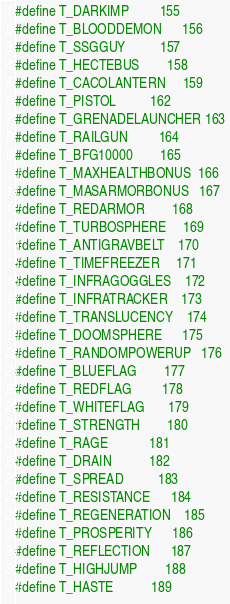<code> <loc_0><loc_0><loc_500><loc_500><_C_>
#define T_DARKIMP         155
#define T_BLOODDEMON      156
#define T_SSGGUY          157
#define T_HECTEBUS        158
#define T_CACOLANTERN     159
#define T_PISTOL          162
#define T_GRENADELAUNCHER 163
#define T_RAILGUN         164
#define T_BFG10000        165
#define T_MAXHEALTHBONUS  166
#define T_MASARMORBONUS   167
#define T_REDARMOR        168
#define T_TURBOSPHERE     169
#define T_ANTIGRAVBELT    170
#define T_TIMEFREEZER     171
#define T_INFRAGOGGLES    172
#define T_INFRATRACKER    173
#define T_TRANSLUCENCY    174
#define T_DOOMSPHERE      175
#define T_RANDOMPOWERUP   176
#define T_BLUEFLAG        177
#define T_REDFLAG         178
#define T_WHITEFLAG       179
#define T_STRENGTH        180
#define T_RAGE            181
#define T_DRAIN           182
#define T_SPREAD          183
#define T_RESISTANCE      184
#define T_REGENERATION    185
#define T_PROSPERITY      186
#define T_REFLECTION      187
#define T_HIGHJUMP        188
#define T_HASTE           189</code> 